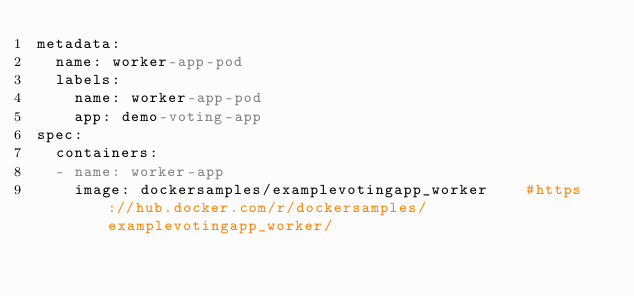Convert code to text. <code><loc_0><loc_0><loc_500><loc_500><_YAML_>metadata:
  name: worker-app-pod
  labels:
    name: worker-app-pod
    app: demo-voting-app    
spec:
  containers:
  - name: worker-app
    image: dockersamples/examplevotingapp_worker    #https://hub.docker.com/r/dockersamples/examplevotingapp_worker/
</code> 